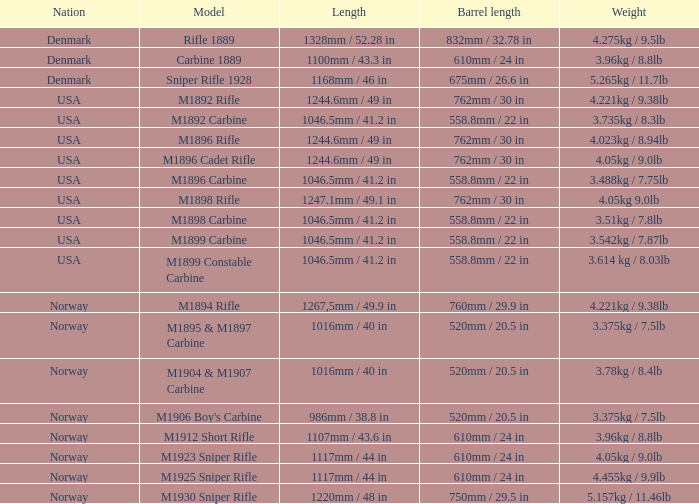What is Nation, when Model is M1895 & M1897 Carbine? Norway. 